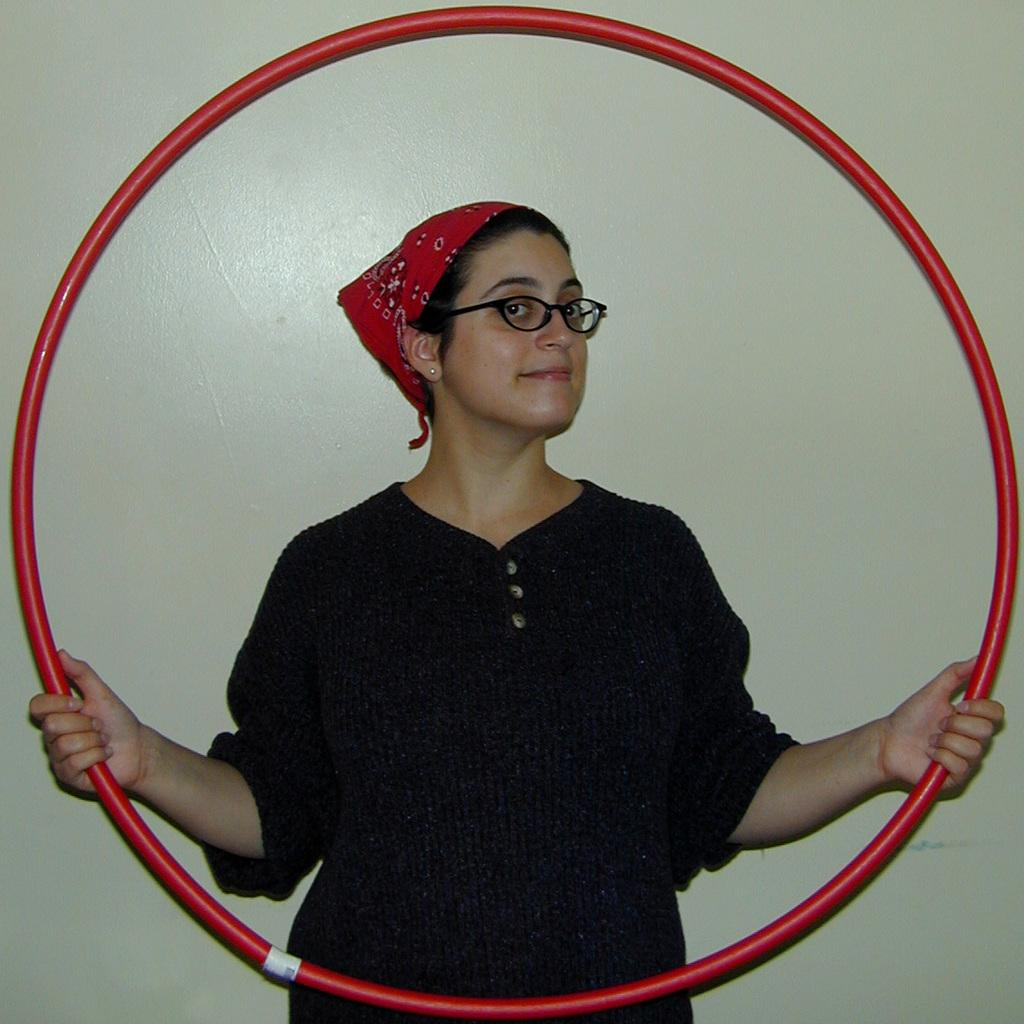Who is present in the image? There is a woman in the image. What is the woman doing in the image? The woman is standing in the image. What object is the woman holding? The woman is holding a ring in the image. What can be seen behind the woman? There is a wall behind the woman in the image. What type of sign is the woman holding in the image? There is no sign present in the image; the woman is holding a ring. Is the woman wearing a crown in the image? There is no crown visible on the woman in the image; she is only holding a ring. 